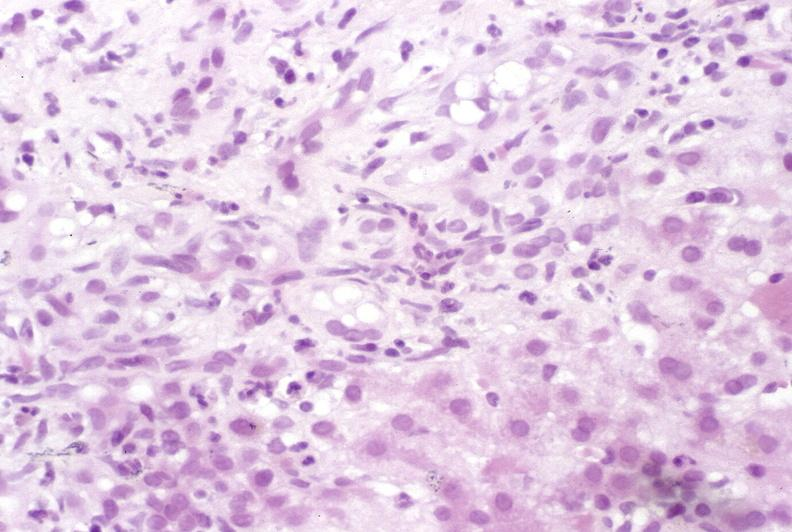what is present?
Answer the question using a single word or phrase. Hepatobiliary 